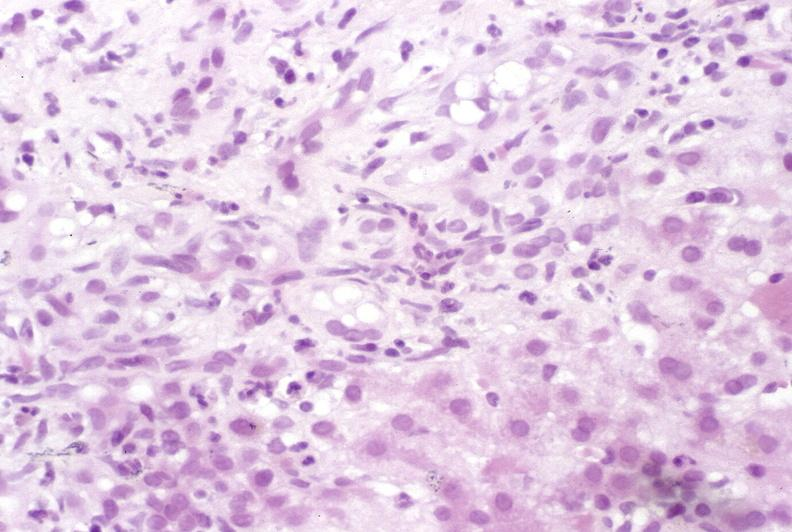what is present?
Answer the question using a single word or phrase. Hepatobiliary 